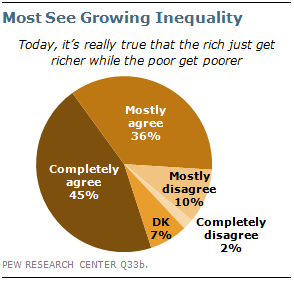Mention a couple of crucial points in this snapshot. The pie chart is divided into five parts. The value difference between "Completely agree" and the sum of "DK" and "Mostly agree" in a pie chart is 2. 